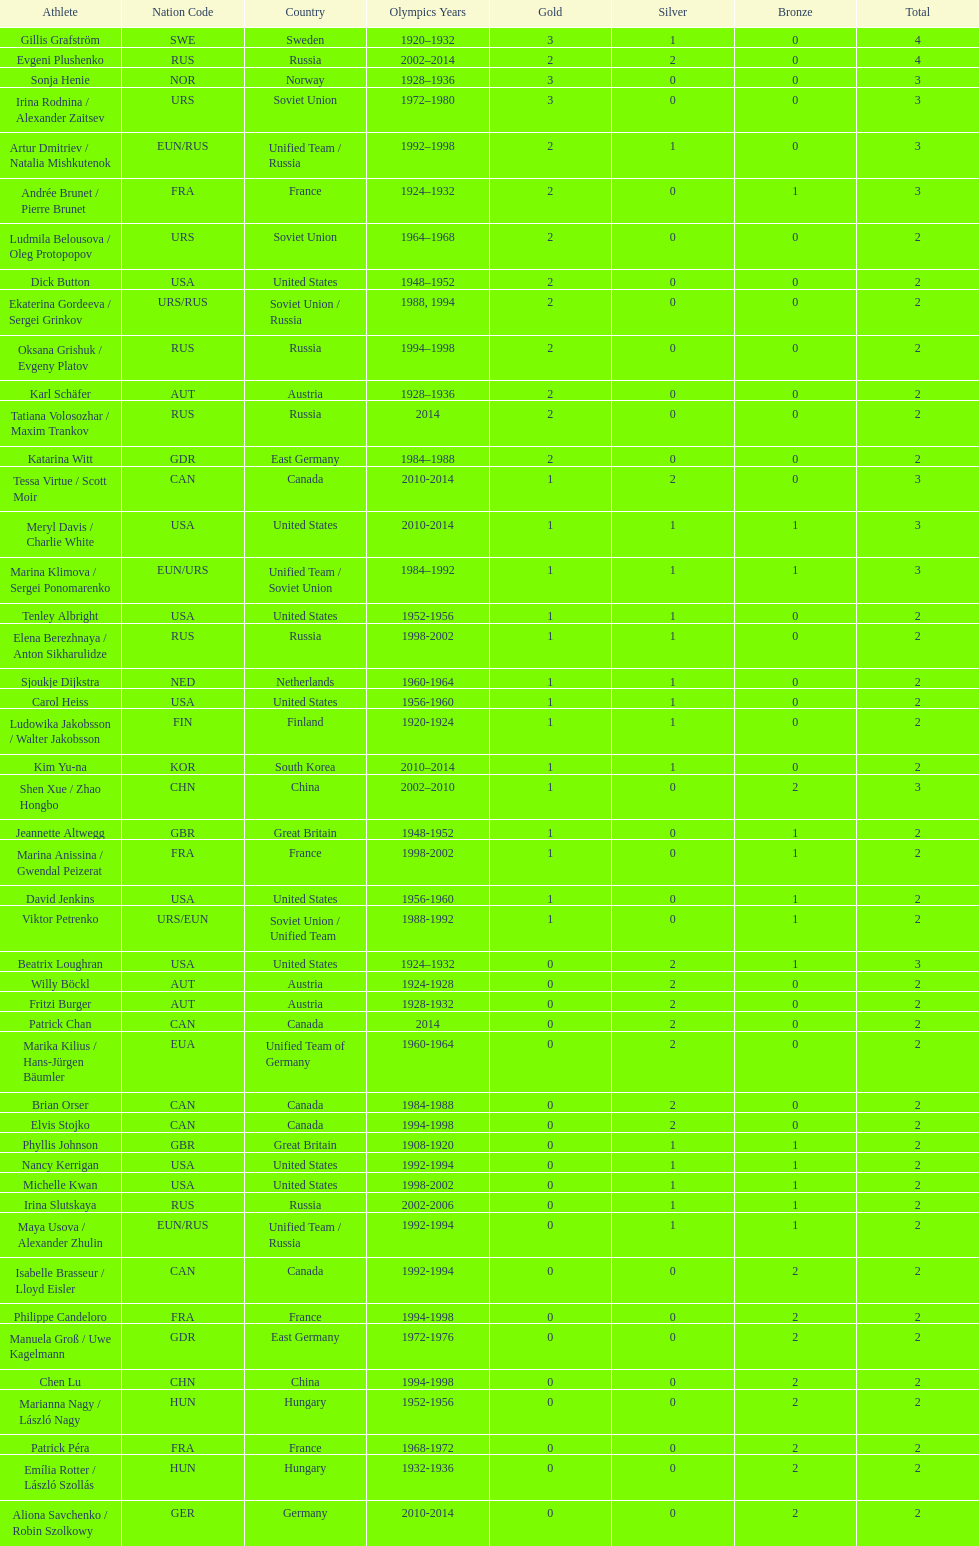How many medals have sweden and norway won combined? 7. 